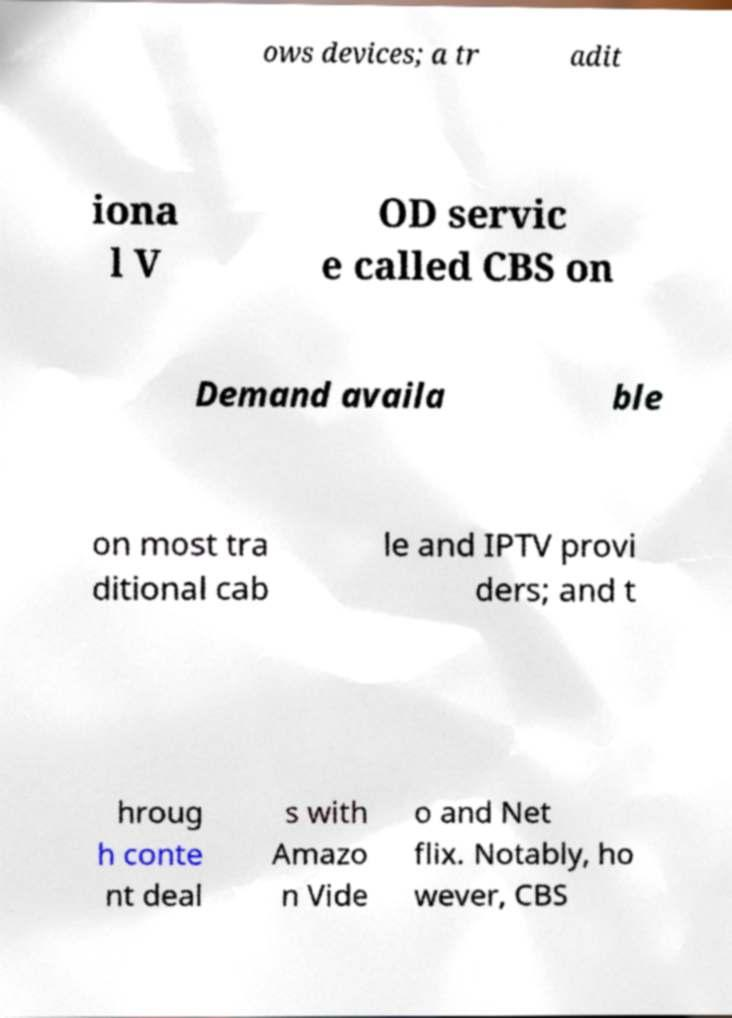Please read and relay the text visible in this image. What does it say? ows devices; a tr adit iona l V OD servic e called CBS on Demand availa ble on most tra ditional cab le and IPTV provi ders; and t hroug h conte nt deal s with Amazo n Vide o and Net flix. Notably, ho wever, CBS 